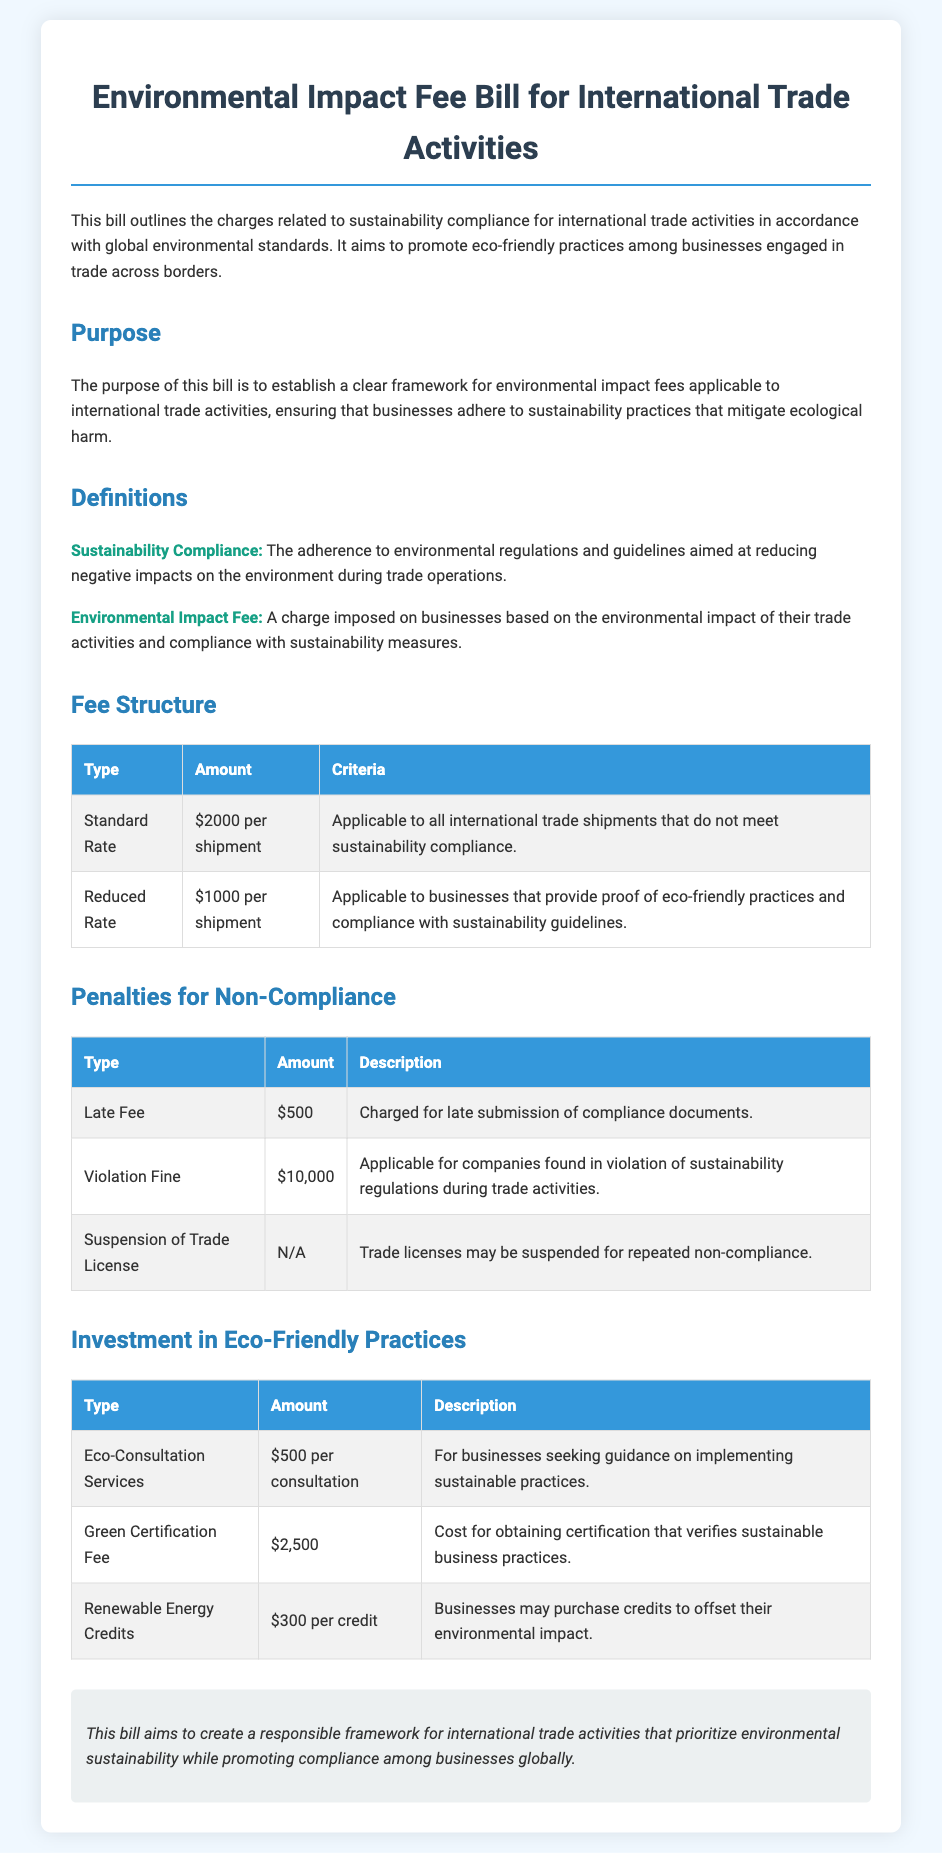What is the standard fee for non-compliance? The standard fee for non-compliance is stated in the Fee Structure section of the document.
Answer: $2000 per shipment What is the reduced fee for businesses that comply? The reduced fee for businesses complying with sustainability guidelines is mentioned in the Fee Structure section.
Answer: $1000 per shipment How much is charged for a late submission of compliance documents? The amount charged for late submission is found in the Penalties for Non-Compliance section.
Answer: $500 What is the penalty for a violation of sustainability regulations? The penalty for a violation can be found in the Penalties for Non-Compliance section of the document.
Answer: $10,000 What is the fee for obtaining Green Certification? The fee for obtaining Green Certification is detailed in the Investment in Eco-Friendly Practices section.
Answer: $2,500 What criteria must be met to qualify for the reduced fee? The criteria for the reduced fee can be inferred from the definitions provided in the document.
Answer: Proof of eco-friendly practices What service costs $500? The service that costs $500 is specified in the Investment in Eco-Friendly Practices section.
Answer: Eco-Consultation Services What actions can lead to the suspension of a trade license? The actions that can lead to suspension of a trade license are outlined in the Penalties for Non-Compliance section.
Answer: Repeated non-compliance What is the purpose of the Environmental Impact Fee Bill? The purpose is stated clearly in the opening section of the document.
Answer: Establish a framework for sustainability compliance 